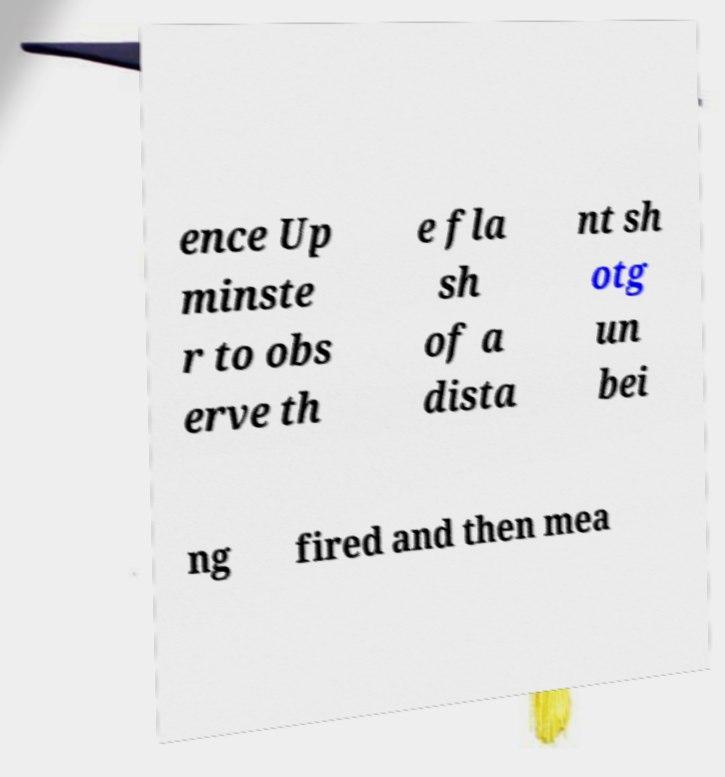Please read and relay the text visible in this image. What does it say? ence Up minste r to obs erve th e fla sh of a dista nt sh otg un bei ng fired and then mea 